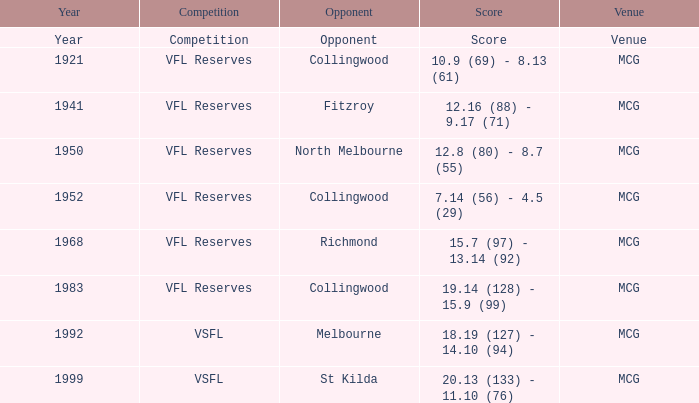Can you parse all the data within this table? {'header': ['Year', 'Competition', 'Opponent', 'Score', 'Venue'], 'rows': [['Year', 'Competition', 'Opponent', 'Score', 'Venue'], ['1921', 'VFL Reserves', 'Collingwood', '10.9 (69) - 8.13 (61)', 'MCG'], ['1941', 'VFL Reserves', 'Fitzroy', '12.16 (88) - 9.17 (71)', 'MCG'], ['1950', 'VFL Reserves', 'North Melbourne', '12.8 (80) - 8.7 (55)', 'MCG'], ['1952', 'VFL Reserves', 'Collingwood', '7.14 (56) - 4.5 (29)', 'MCG'], ['1968', 'VFL Reserves', 'Richmond', '15.7 (97) - 13.14 (92)', 'MCG'], ['1983', 'VFL Reserves', 'Collingwood', '19.14 (128) - 15.9 (99)', 'MCG'], ['1992', 'VSFL', 'Melbourne', '18.19 (127) - 14.10 (94)', 'MCG'], ['1999', 'VSFL', 'St Kilda', '20.13 (133) - 11.10 (76)', 'MCG']]} At what venue did the team from Collingwood score 7.14 (56) - 4.5 (29)? MCG. 